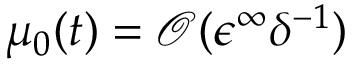Convert formula to latex. <formula><loc_0><loc_0><loc_500><loc_500>\mu _ { 0 } ( t ) = \mathcal { O } ( \epsilon ^ { \infty } \delta ^ { - 1 } )</formula> 